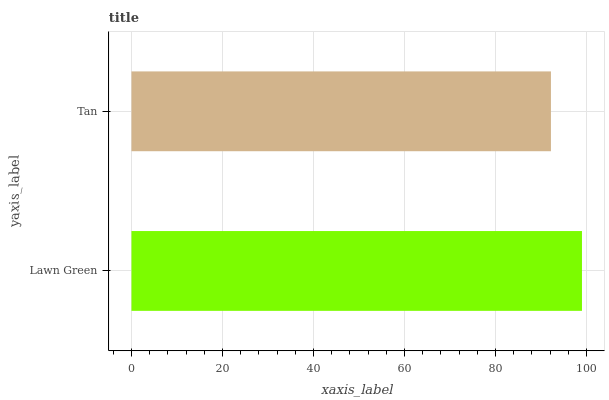Is Tan the minimum?
Answer yes or no. Yes. Is Lawn Green the maximum?
Answer yes or no. Yes. Is Tan the maximum?
Answer yes or no. No. Is Lawn Green greater than Tan?
Answer yes or no. Yes. Is Tan less than Lawn Green?
Answer yes or no. Yes. Is Tan greater than Lawn Green?
Answer yes or no. No. Is Lawn Green less than Tan?
Answer yes or no. No. Is Lawn Green the high median?
Answer yes or no. Yes. Is Tan the low median?
Answer yes or no. Yes. Is Tan the high median?
Answer yes or no. No. Is Lawn Green the low median?
Answer yes or no. No. 